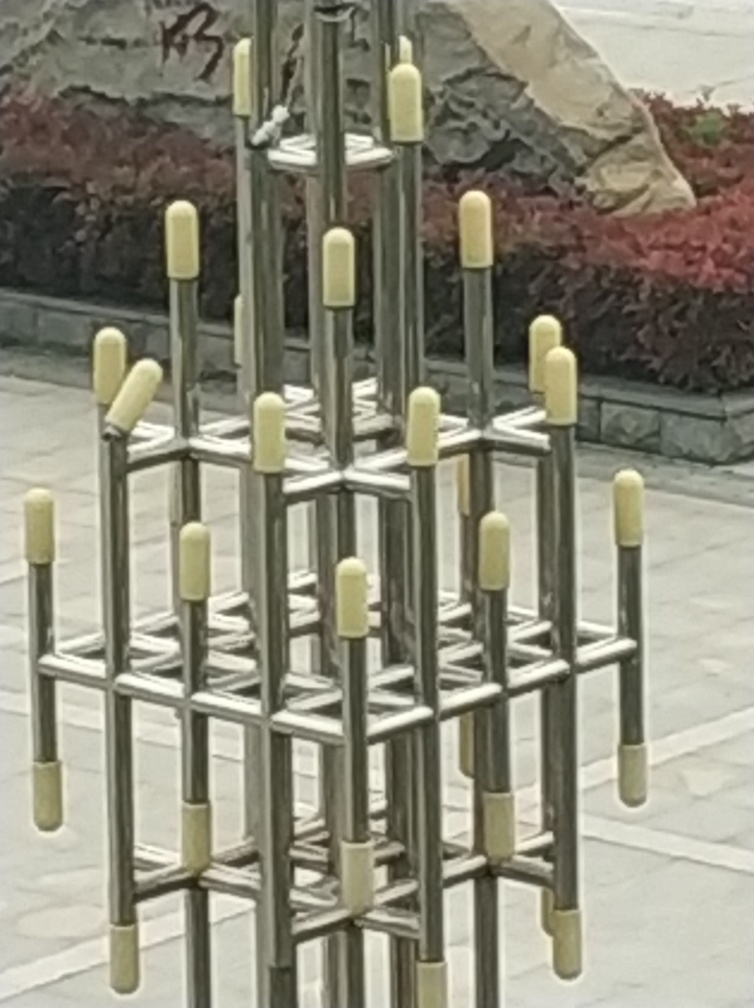What is the main object in the image and what could be its purpose? The main object in the image appears to be a modern metallic sculpture featuring a geometric framework. Its purpose could range from being purely aesthetic as a piece of public art to having a functional role, perhaps as part of an outdoor installation or playground equipment. 